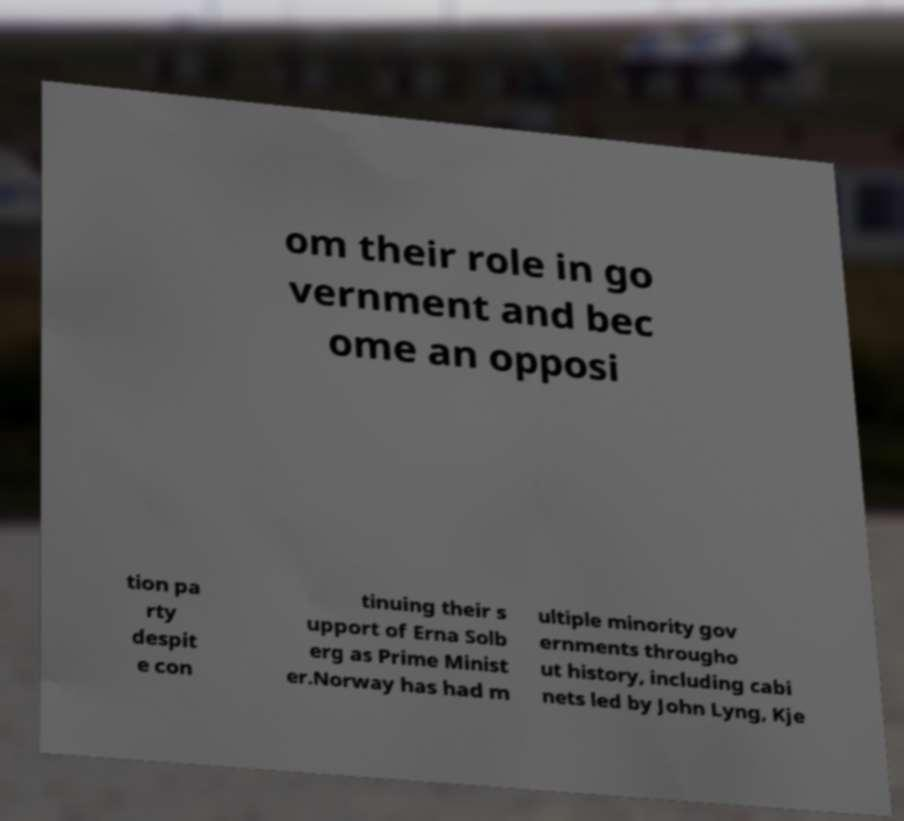Could you extract and type out the text from this image? om their role in go vernment and bec ome an opposi tion pa rty despit e con tinuing their s upport of Erna Solb erg as Prime Minist er.Norway has had m ultiple minority gov ernments througho ut history, including cabi nets led by John Lyng, Kje 